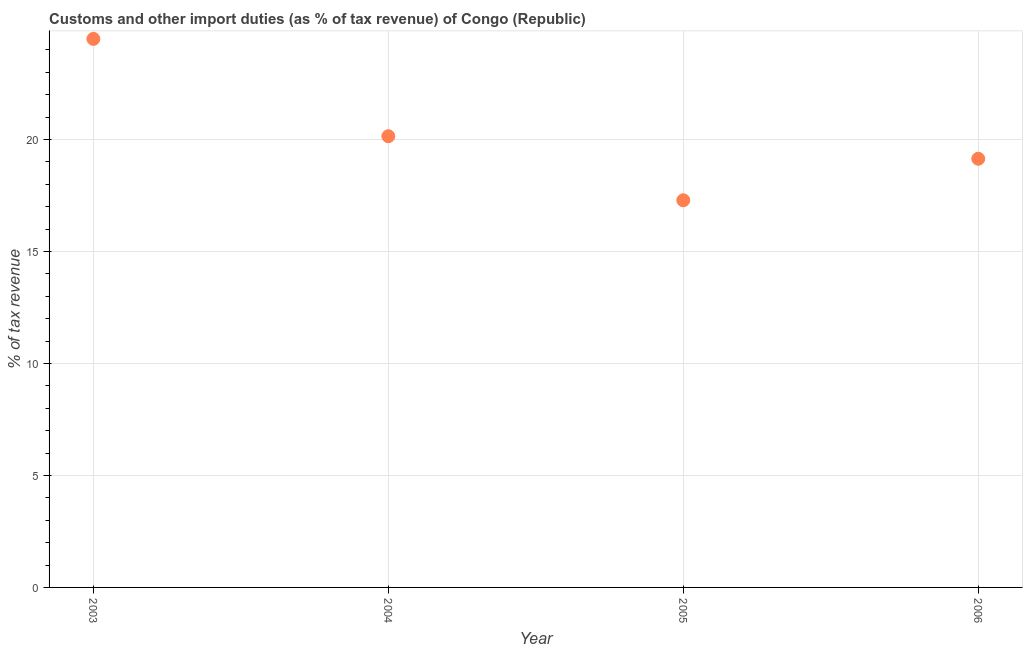What is the customs and other import duties in 2003?
Offer a very short reply. 24.49. Across all years, what is the maximum customs and other import duties?
Your answer should be compact. 24.49. Across all years, what is the minimum customs and other import duties?
Ensure brevity in your answer.  17.28. What is the sum of the customs and other import duties?
Offer a terse response. 81.05. What is the difference between the customs and other import duties in 2005 and 2006?
Provide a short and direct response. -1.85. What is the average customs and other import duties per year?
Your answer should be compact. 20.26. What is the median customs and other import duties?
Ensure brevity in your answer.  19.64. What is the ratio of the customs and other import duties in 2003 to that in 2004?
Offer a terse response. 1.22. Is the difference between the customs and other import duties in 2004 and 2006 greater than the difference between any two years?
Your answer should be very brief. No. What is the difference between the highest and the second highest customs and other import duties?
Give a very brief answer. 4.34. Is the sum of the customs and other import duties in 2003 and 2006 greater than the maximum customs and other import duties across all years?
Keep it short and to the point. Yes. What is the difference between the highest and the lowest customs and other import duties?
Make the answer very short. 7.2. In how many years, is the customs and other import duties greater than the average customs and other import duties taken over all years?
Keep it short and to the point. 1. How many dotlines are there?
Offer a terse response. 1. What is the difference between two consecutive major ticks on the Y-axis?
Offer a terse response. 5. Are the values on the major ticks of Y-axis written in scientific E-notation?
Keep it short and to the point. No. Does the graph contain any zero values?
Ensure brevity in your answer.  No. Does the graph contain grids?
Keep it short and to the point. Yes. What is the title of the graph?
Your answer should be very brief. Customs and other import duties (as % of tax revenue) of Congo (Republic). What is the label or title of the Y-axis?
Provide a short and direct response. % of tax revenue. What is the % of tax revenue in 2003?
Ensure brevity in your answer.  24.49. What is the % of tax revenue in 2004?
Your answer should be compact. 20.14. What is the % of tax revenue in 2005?
Your response must be concise. 17.28. What is the % of tax revenue in 2006?
Offer a very short reply. 19.14. What is the difference between the % of tax revenue in 2003 and 2004?
Offer a very short reply. 4.34. What is the difference between the % of tax revenue in 2003 and 2005?
Your answer should be compact. 7.2. What is the difference between the % of tax revenue in 2003 and 2006?
Your response must be concise. 5.35. What is the difference between the % of tax revenue in 2004 and 2005?
Provide a succinct answer. 2.86. What is the difference between the % of tax revenue in 2004 and 2006?
Offer a terse response. 1.01. What is the difference between the % of tax revenue in 2005 and 2006?
Provide a short and direct response. -1.85. What is the ratio of the % of tax revenue in 2003 to that in 2004?
Your answer should be compact. 1.22. What is the ratio of the % of tax revenue in 2003 to that in 2005?
Your answer should be compact. 1.42. What is the ratio of the % of tax revenue in 2003 to that in 2006?
Your answer should be very brief. 1.28. What is the ratio of the % of tax revenue in 2004 to that in 2005?
Provide a succinct answer. 1.17. What is the ratio of the % of tax revenue in 2004 to that in 2006?
Keep it short and to the point. 1.05. What is the ratio of the % of tax revenue in 2005 to that in 2006?
Your response must be concise. 0.9. 